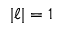Convert formula to latex. <formula><loc_0><loc_0><loc_500><loc_500>| \ell | = 1</formula> 